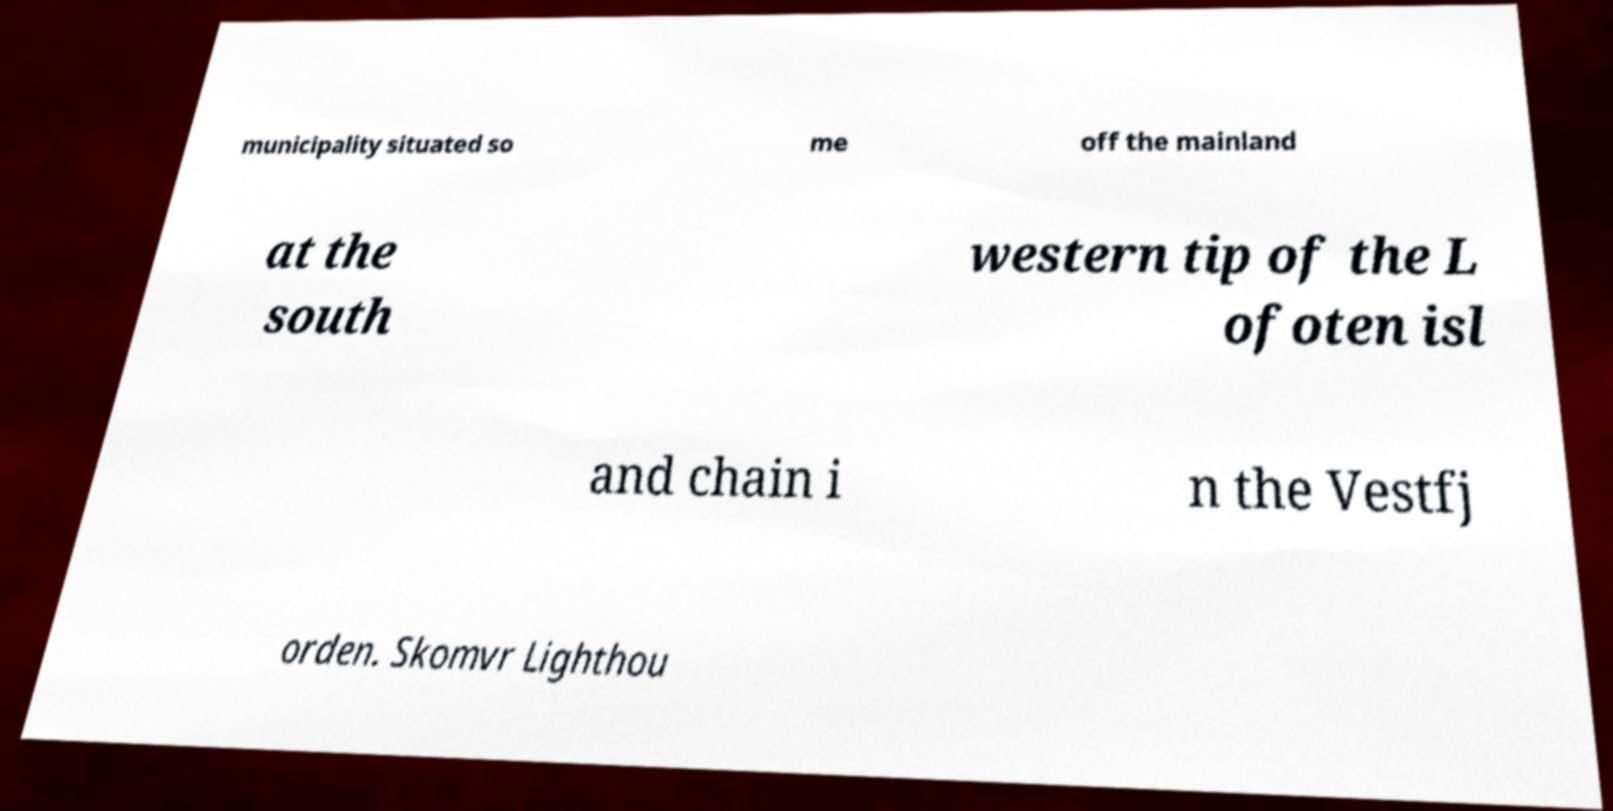There's text embedded in this image that I need extracted. Can you transcribe it verbatim? municipality situated so me off the mainland at the south western tip of the L ofoten isl and chain i n the Vestfj orden. Skomvr Lighthou 